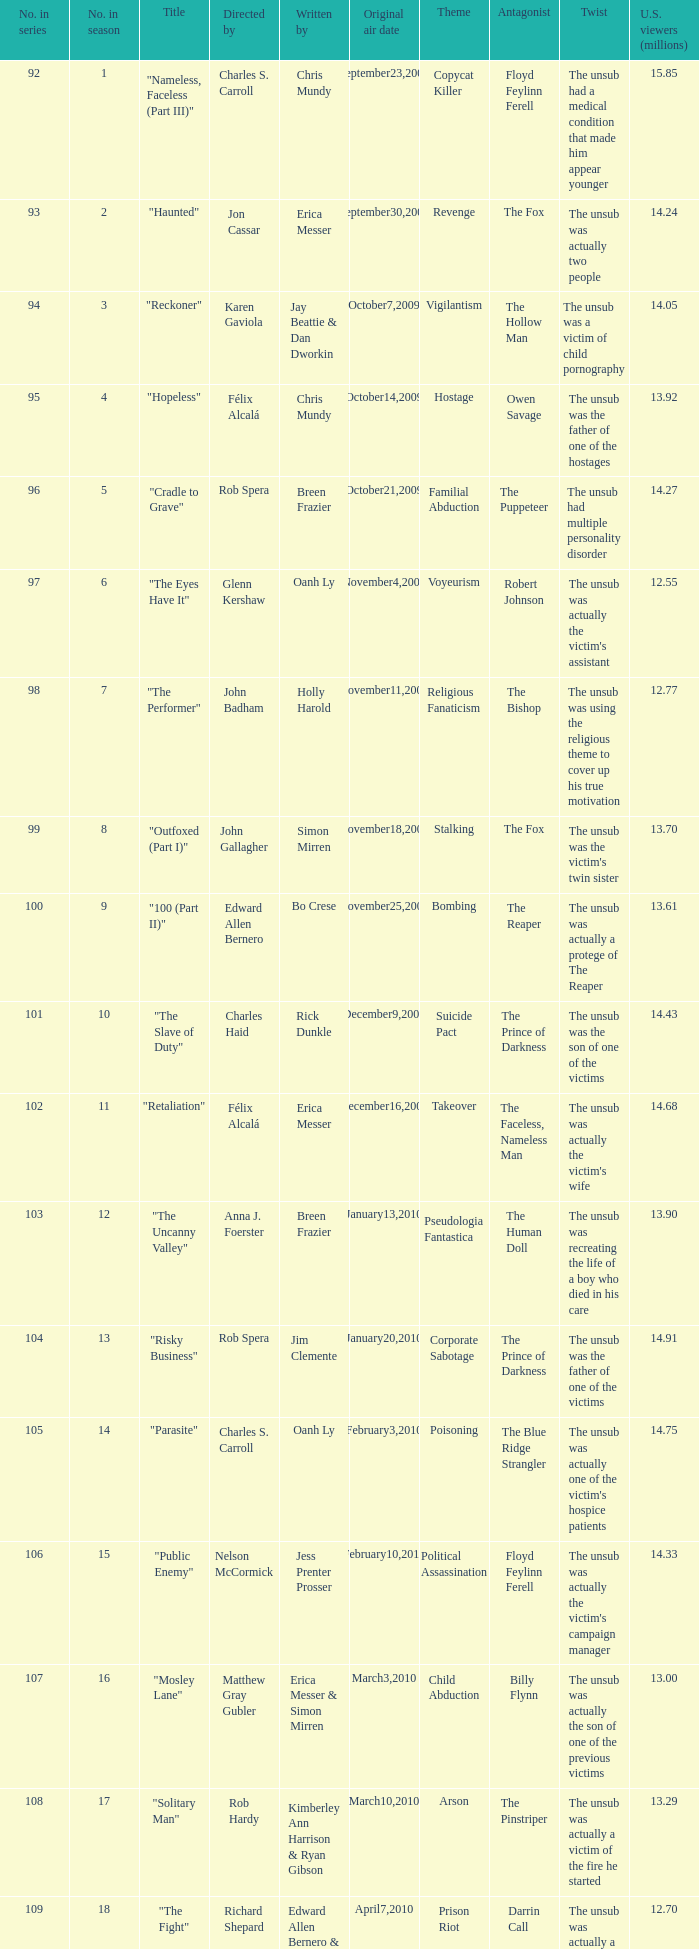What was the original air date for the episode with 13.92 million us viewers? October14,2009. 